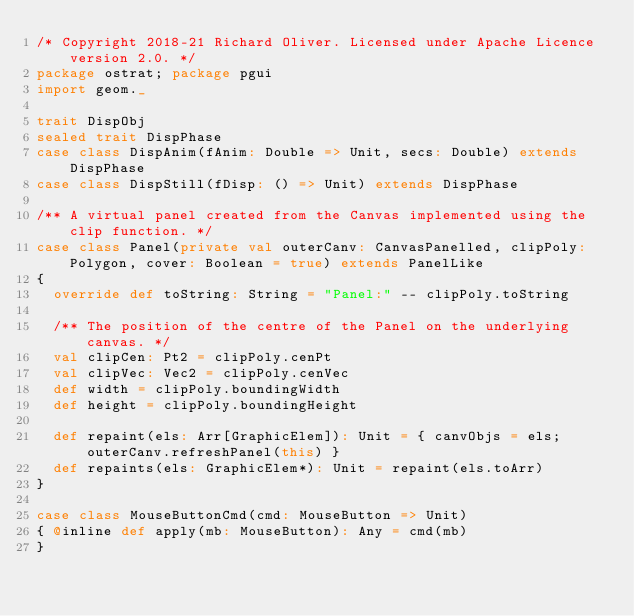Convert code to text. <code><loc_0><loc_0><loc_500><loc_500><_Scala_>/* Copyright 2018-21 Richard Oliver. Licensed under Apache Licence version 2.0. */
package ostrat; package pgui
import geom._

trait DispObj
sealed trait DispPhase
case class DispAnim(fAnim: Double => Unit, secs: Double) extends DispPhase
case class DispStill(fDisp: () => Unit) extends DispPhase

/** A virtual panel created from the Canvas implemented using the clip function. */
case class Panel(private val outerCanv: CanvasPanelled, clipPoly: Polygon, cover: Boolean = true) extends PanelLike
{
  override def toString: String = "Panel:" -- clipPoly.toString

  /** The position of the centre of the Panel on the underlying canvas. */
  val clipCen: Pt2 = clipPoly.cenPt
  val clipVec: Vec2 = clipPoly.cenVec
  def width = clipPoly.boundingWidth
  def height = clipPoly.boundingHeight

  def repaint(els: Arr[GraphicElem]): Unit = { canvObjs = els; outerCanv.refreshPanel(this) }
  def repaints(els: GraphicElem*): Unit = repaint(els.toArr)
}

case class MouseButtonCmd(cmd: MouseButton => Unit)
{ @inline def apply(mb: MouseButton): Any = cmd(mb)
}</code> 